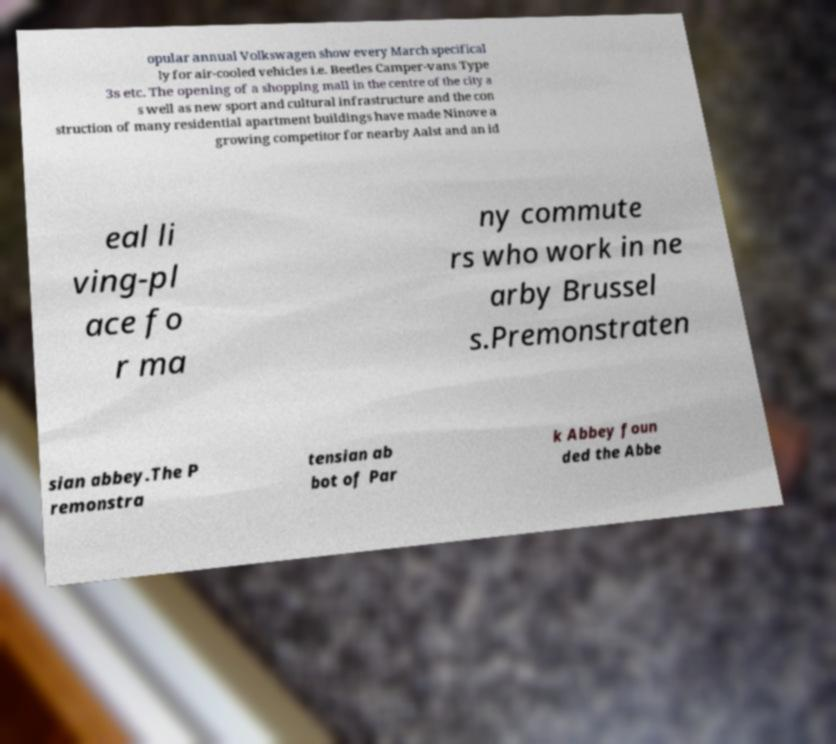For documentation purposes, I need the text within this image transcribed. Could you provide that? opular annual Volkswagen show every March specifical ly for air-cooled vehicles i.e. Beetles Camper-vans Type 3s etc. The opening of a shopping mall in the centre of the city a s well as new sport and cultural infrastructure and the con struction of many residential apartment buildings have made Ninove a growing competitor for nearby Aalst and an id eal li ving-pl ace fo r ma ny commute rs who work in ne arby Brussel s.Premonstraten sian abbey.The P remonstra tensian ab bot of Par k Abbey foun ded the Abbe 